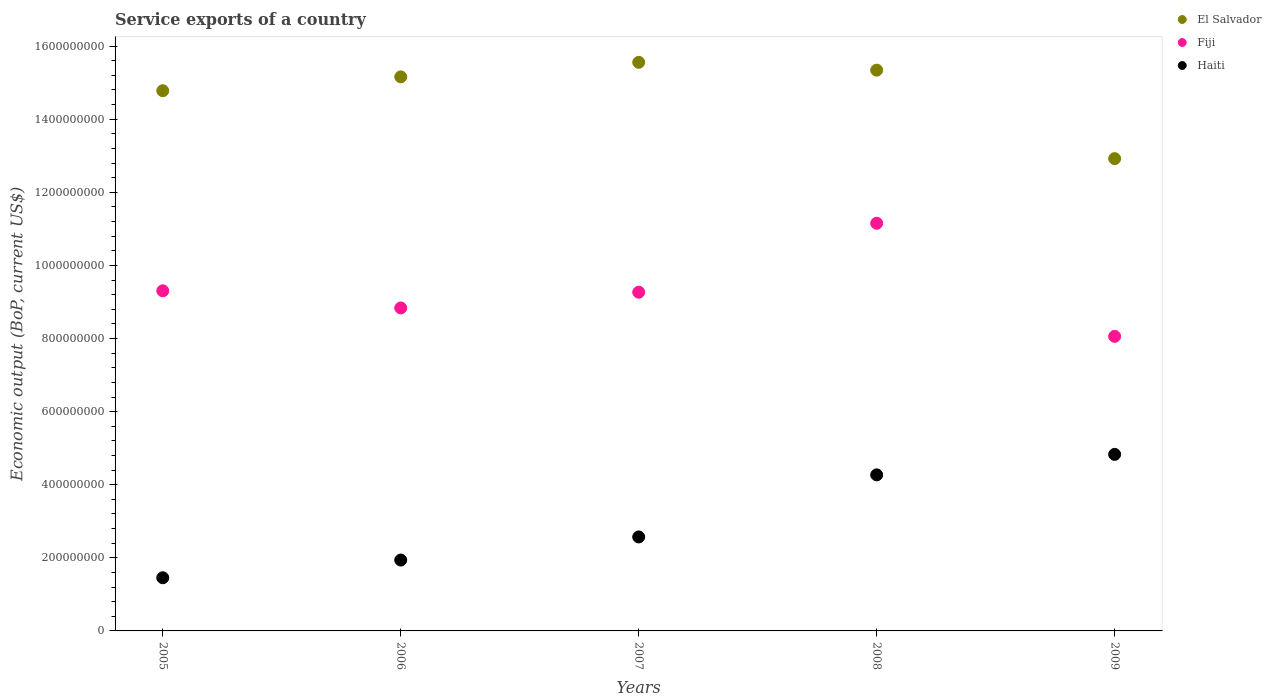What is the service exports in Haiti in 2009?
Make the answer very short. 4.83e+08. Across all years, what is the maximum service exports in Haiti?
Your answer should be compact. 4.83e+08. Across all years, what is the minimum service exports in El Salvador?
Your answer should be very brief. 1.29e+09. In which year was the service exports in El Salvador maximum?
Your answer should be compact. 2007. What is the total service exports in Haiti in the graph?
Keep it short and to the point. 1.51e+09. What is the difference between the service exports in Fiji in 2007 and that in 2008?
Provide a succinct answer. -1.89e+08. What is the difference between the service exports in Haiti in 2006 and the service exports in El Salvador in 2007?
Provide a succinct answer. -1.36e+09. What is the average service exports in Fiji per year?
Make the answer very short. 9.32e+08. In the year 2006, what is the difference between the service exports in Fiji and service exports in El Salvador?
Provide a short and direct response. -6.32e+08. In how many years, is the service exports in Fiji greater than 1040000000 US$?
Offer a very short reply. 1. What is the ratio of the service exports in El Salvador in 2005 to that in 2007?
Give a very brief answer. 0.95. What is the difference between the highest and the second highest service exports in El Salvador?
Make the answer very short. 2.14e+07. What is the difference between the highest and the lowest service exports in El Salvador?
Provide a succinct answer. 2.63e+08. Is it the case that in every year, the sum of the service exports in El Salvador and service exports in Haiti  is greater than the service exports in Fiji?
Offer a very short reply. Yes. Does the service exports in Haiti monotonically increase over the years?
Your response must be concise. Yes. Are the values on the major ticks of Y-axis written in scientific E-notation?
Make the answer very short. No. Does the graph contain grids?
Ensure brevity in your answer.  No. How are the legend labels stacked?
Offer a very short reply. Vertical. What is the title of the graph?
Keep it short and to the point. Service exports of a country. What is the label or title of the Y-axis?
Provide a short and direct response. Economic output (BoP, current US$). What is the Economic output (BoP, current US$) of El Salvador in 2005?
Offer a terse response. 1.48e+09. What is the Economic output (BoP, current US$) in Fiji in 2005?
Offer a very short reply. 9.31e+08. What is the Economic output (BoP, current US$) of Haiti in 2005?
Your response must be concise. 1.45e+08. What is the Economic output (BoP, current US$) of El Salvador in 2006?
Offer a terse response. 1.52e+09. What is the Economic output (BoP, current US$) in Fiji in 2006?
Your answer should be compact. 8.84e+08. What is the Economic output (BoP, current US$) of Haiti in 2006?
Your answer should be compact. 1.94e+08. What is the Economic output (BoP, current US$) of El Salvador in 2007?
Offer a terse response. 1.56e+09. What is the Economic output (BoP, current US$) of Fiji in 2007?
Offer a terse response. 9.27e+08. What is the Economic output (BoP, current US$) of Haiti in 2007?
Give a very brief answer. 2.57e+08. What is the Economic output (BoP, current US$) in El Salvador in 2008?
Ensure brevity in your answer.  1.53e+09. What is the Economic output (BoP, current US$) of Fiji in 2008?
Offer a very short reply. 1.12e+09. What is the Economic output (BoP, current US$) of Haiti in 2008?
Provide a succinct answer. 4.27e+08. What is the Economic output (BoP, current US$) of El Salvador in 2009?
Make the answer very short. 1.29e+09. What is the Economic output (BoP, current US$) in Fiji in 2009?
Your answer should be very brief. 8.06e+08. What is the Economic output (BoP, current US$) in Haiti in 2009?
Provide a succinct answer. 4.83e+08. Across all years, what is the maximum Economic output (BoP, current US$) in El Salvador?
Make the answer very short. 1.56e+09. Across all years, what is the maximum Economic output (BoP, current US$) in Fiji?
Make the answer very short. 1.12e+09. Across all years, what is the maximum Economic output (BoP, current US$) in Haiti?
Ensure brevity in your answer.  4.83e+08. Across all years, what is the minimum Economic output (BoP, current US$) of El Salvador?
Keep it short and to the point. 1.29e+09. Across all years, what is the minimum Economic output (BoP, current US$) in Fiji?
Offer a terse response. 8.06e+08. Across all years, what is the minimum Economic output (BoP, current US$) in Haiti?
Offer a very short reply. 1.45e+08. What is the total Economic output (BoP, current US$) in El Salvador in the graph?
Your answer should be compact. 7.38e+09. What is the total Economic output (BoP, current US$) of Fiji in the graph?
Your response must be concise. 4.66e+09. What is the total Economic output (BoP, current US$) in Haiti in the graph?
Your answer should be compact. 1.51e+09. What is the difference between the Economic output (BoP, current US$) of El Salvador in 2005 and that in 2006?
Keep it short and to the point. -3.79e+07. What is the difference between the Economic output (BoP, current US$) in Fiji in 2005 and that in 2006?
Ensure brevity in your answer.  4.68e+07. What is the difference between the Economic output (BoP, current US$) of Haiti in 2005 and that in 2006?
Offer a very short reply. -4.85e+07. What is the difference between the Economic output (BoP, current US$) of El Salvador in 2005 and that in 2007?
Offer a terse response. -7.76e+07. What is the difference between the Economic output (BoP, current US$) of Fiji in 2005 and that in 2007?
Your response must be concise. 3.80e+06. What is the difference between the Economic output (BoP, current US$) of Haiti in 2005 and that in 2007?
Offer a terse response. -1.12e+08. What is the difference between the Economic output (BoP, current US$) of El Salvador in 2005 and that in 2008?
Give a very brief answer. -5.62e+07. What is the difference between the Economic output (BoP, current US$) in Fiji in 2005 and that in 2008?
Give a very brief answer. -1.85e+08. What is the difference between the Economic output (BoP, current US$) in Haiti in 2005 and that in 2008?
Your answer should be compact. -2.82e+08. What is the difference between the Economic output (BoP, current US$) in El Salvador in 2005 and that in 2009?
Your answer should be compact. 1.86e+08. What is the difference between the Economic output (BoP, current US$) of Fiji in 2005 and that in 2009?
Your answer should be compact. 1.25e+08. What is the difference between the Economic output (BoP, current US$) in Haiti in 2005 and that in 2009?
Make the answer very short. -3.38e+08. What is the difference between the Economic output (BoP, current US$) in El Salvador in 2006 and that in 2007?
Offer a terse response. -3.97e+07. What is the difference between the Economic output (BoP, current US$) of Fiji in 2006 and that in 2007?
Offer a terse response. -4.30e+07. What is the difference between the Economic output (BoP, current US$) in Haiti in 2006 and that in 2007?
Offer a terse response. -6.32e+07. What is the difference between the Economic output (BoP, current US$) in El Salvador in 2006 and that in 2008?
Offer a very short reply. -1.83e+07. What is the difference between the Economic output (BoP, current US$) in Fiji in 2006 and that in 2008?
Make the answer very short. -2.32e+08. What is the difference between the Economic output (BoP, current US$) in Haiti in 2006 and that in 2008?
Ensure brevity in your answer.  -2.33e+08. What is the difference between the Economic output (BoP, current US$) in El Salvador in 2006 and that in 2009?
Keep it short and to the point. 2.24e+08. What is the difference between the Economic output (BoP, current US$) in Fiji in 2006 and that in 2009?
Provide a succinct answer. 7.78e+07. What is the difference between the Economic output (BoP, current US$) in Haiti in 2006 and that in 2009?
Ensure brevity in your answer.  -2.89e+08. What is the difference between the Economic output (BoP, current US$) in El Salvador in 2007 and that in 2008?
Offer a terse response. 2.14e+07. What is the difference between the Economic output (BoP, current US$) of Fiji in 2007 and that in 2008?
Your response must be concise. -1.89e+08. What is the difference between the Economic output (BoP, current US$) of Haiti in 2007 and that in 2008?
Your answer should be very brief. -1.70e+08. What is the difference between the Economic output (BoP, current US$) in El Salvador in 2007 and that in 2009?
Your answer should be very brief. 2.63e+08. What is the difference between the Economic output (BoP, current US$) in Fiji in 2007 and that in 2009?
Provide a short and direct response. 1.21e+08. What is the difference between the Economic output (BoP, current US$) of Haiti in 2007 and that in 2009?
Offer a terse response. -2.26e+08. What is the difference between the Economic output (BoP, current US$) of El Salvador in 2008 and that in 2009?
Give a very brief answer. 2.42e+08. What is the difference between the Economic output (BoP, current US$) in Fiji in 2008 and that in 2009?
Your answer should be compact. 3.09e+08. What is the difference between the Economic output (BoP, current US$) of Haiti in 2008 and that in 2009?
Your answer should be very brief. -5.60e+07. What is the difference between the Economic output (BoP, current US$) in El Salvador in 2005 and the Economic output (BoP, current US$) in Fiji in 2006?
Your answer should be very brief. 5.94e+08. What is the difference between the Economic output (BoP, current US$) in El Salvador in 2005 and the Economic output (BoP, current US$) in Haiti in 2006?
Offer a very short reply. 1.28e+09. What is the difference between the Economic output (BoP, current US$) of Fiji in 2005 and the Economic output (BoP, current US$) of Haiti in 2006?
Provide a succinct answer. 7.37e+08. What is the difference between the Economic output (BoP, current US$) in El Salvador in 2005 and the Economic output (BoP, current US$) in Fiji in 2007?
Ensure brevity in your answer.  5.51e+08. What is the difference between the Economic output (BoP, current US$) in El Salvador in 2005 and the Economic output (BoP, current US$) in Haiti in 2007?
Offer a very short reply. 1.22e+09. What is the difference between the Economic output (BoP, current US$) of Fiji in 2005 and the Economic output (BoP, current US$) of Haiti in 2007?
Provide a succinct answer. 6.73e+08. What is the difference between the Economic output (BoP, current US$) in El Salvador in 2005 and the Economic output (BoP, current US$) in Fiji in 2008?
Your answer should be very brief. 3.63e+08. What is the difference between the Economic output (BoP, current US$) in El Salvador in 2005 and the Economic output (BoP, current US$) in Haiti in 2008?
Provide a succinct answer. 1.05e+09. What is the difference between the Economic output (BoP, current US$) of Fiji in 2005 and the Economic output (BoP, current US$) of Haiti in 2008?
Provide a succinct answer. 5.04e+08. What is the difference between the Economic output (BoP, current US$) in El Salvador in 2005 and the Economic output (BoP, current US$) in Fiji in 2009?
Make the answer very short. 6.72e+08. What is the difference between the Economic output (BoP, current US$) of El Salvador in 2005 and the Economic output (BoP, current US$) of Haiti in 2009?
Make the answer very short. 9.95e+08. What is the difference between the Economic output (BoP, current US$) of Fiji in 2005 and the Economic output (BoP, current US$) of Haiti in 2009?
Offer a terse response. 4.48e+08. What is the difference between the Economic output (BoP, current US$) of El Salvador in 2006 and the Economic output (BoP, current US$) of Fiji in 2007?
Provide a succinct answer. 5.89e+08. What is the difference between the Economic output (BoP, current US$) in El Salvador in 2006 and the Economic output (BoP, current US$) in Haiti in 2007?
Your response must be concise. 1.26e+09. What is the difference between the Economic output (BoP, current US$) in Fiji in 2006 and the Economic output (BoP, current US$) in Haiti in 2007?
Your answer should be very brief. 6.27e+08. What is the difference between the Economic output (BoP, current US$) in El Salvador in 2006 and the Economic output (BoP, current US$) in Fiji in 2008?
Offer a terse response. 4.01e+08. What is the difference between the Economic output (BoP, current US$) in El Salvador in 2006 and the Economic output (BoP, current US$) in Haiti in 2008?
Your response must be concise. 1.09e+09. What is the difference between the Economic output (BoP, current US$) in Fiji in 2006 and the Economic output (BoP, current US$) in Haiti in 2008?
Offer a very short reply. 4.57e+08. What is the difference between the Economic output (BoP, current US$) of El Salvador in 2006 and the Economic output (BoP, current US$) of Fiji in 2009?
Make the answer very short. 7.10e+08. What is the difference between the Economic output (BoP, current US$) in El Salvador in 2006 and the Economic output (BoP, current US$) in Haiti in 2009?
Your answer should be compact. 1.03e+09. What is the difference between the Economic output (BoP, current US$) of Fiji in 2006 and the Economic output (BoP, current US$) of Haiti in 2009?
Provide a succinct answer. 4.01e+08. What is the difference between the Economic output (BoP, current US$) in El Salvador in 2007 and the Economic output (BoP, current US$) in Fiji in 2008?
Provide a short and direct response. 4.40e+08. What is the difference between the Economic output (BoP, current US$) in El Salvador in 2007 and the Economic output (BoP, current US$) in Haiti in 2008?
Offer a very short reply. 1.13e+09. What is the difference between the Economic output (BoP, current US$) of Fiji in 2007 and the Economic output (BoP, current US$) of Haiti in 2008?
Ensure brevity in your answer.  5.00e+08. What is the difference between the Economic output (BoP, current US$) of El Salvador in 2007 and the Economic output (BoP, current US$) of Fiji in 2009?
Provide a short and direct response. 7.50e+08. What is the difference between the Economic output (BoP, current US$) of El Salvador in 2007 and the Economic output (BoP, current US$) of Haiti in 2009?
Provide a short and direct response. 1.07e+09. What is the difference between the Economic output (BoP, current US$) of Fiji in 2007 and the Economic output (BoP, current US$) of Haiti in 2009?
Provide a succinct answer. 4.44e+08. What is the difference between the Economic output (BoP, current US$) in El Salvador in 2008 and the Economic output (BoP, current US$) in Fiji in 2009?
Provide a short and direct response. 7.28e+08. What is the difference between the Economic output (BoP, current US$) in El Salvador in 2008 and the Economic output (BoP, current US$) in Haiti in 2009?
Your answer should be very brief. 1.05e+09. What is the difference between the Economic output (BoP, current US$) of Fiji in 2008 and the Economic output (BoP, current US$) of Haiti in 2009?
Your answer should be very brief. 6.32e+08. What is the average Economic output (BoP, current US$) of El Salvador per year?
Your answer should be compact. 1.48e+09. What is the average Economic output (BoP, current US$) in Fiji per year?
Your response must be concise. 9.32e+08. What is the average Economic output (BoP, current US$) in Haiti per year?
Keep it short and to the point. 3.01e+08. In the year 2005, what is the difference between the Economic output (BoP, current US$) in El Salvador and Economic output (BoP, current US$) in Fiji?
Give a very brief answer. 5.47e+08. In the year 2005, what is the difference between the Economic output (BoP, current US$) of El Salvador and Economic output (BoP, current US$) of Haiti?
Make the answer very short. 1.33e+09. In the year 2005, what is the difference between the Economic output (BoP, current US$) of Fiji and Economic output (BoP, current US$) of Haiti?
Offer a very short reply. 7.85e+08. In the year 2006, what is the difference between the Economic output (BoP, current US$) in El Salvador and Economic output (BoP, current US$) in Fiji?
Offer a terse response. 6.32e+08. In the year 2006, what is the difference between the Economic output (BoP, current US$) of El Salvador and Economic output (BoP, current US$) of Haiti?
Make the answer very short. 1.32e+09. In the year 2006, what is the difference between the Economic output (BoP, current US$) in Fiji and Economic output (BoP, current US$) in Haiti?
Ensure brevity in your answer.  6.90e+08. In the year 2007, what is the difference between the Economic output (BoP, current US$) in El Salvador and Economic output (BoP, current US$) in Fiji?
Give a very brief answer. 6.29e+08. In the year 2007, what is the difference between the Economic output (BoP, current US$) of El Salvador and Economic output (BoP, current US$) of Haiti?
Provide a short and direct response. 1.30e+09. In the year 2007, what is the difference between the Economic output (BoP, current US$) in Fiji and Economic output (BoP, current US$) in Haiti?
Your answer should be very brief. 6.70e+08. In the year 2008, what is the difference between the Economic output (BoP, current US$) in El Salvador and Economic output (BoP, current US$) in Fiji?
Give a very brief answer. 4.19e+08. In the year 2008, what is the difference between the Economic output (BoP, current US$) of El Salvador and Economic output (BoP, current US$) of Haiti?
Give a very brief answer. 1.11e+09. In the year 2008, what is the difference between the Economic output (BoP, current US$) in Fiji and Economic output (BoP, current US$) in Haiti?
Your response must be concise. 6.88e+08. In the year 2009, what is the difference between the Economic output (BoP, current US$) of El Salvador and Economic output (BoP, current US$) of Fiji?
Provide a succinct answer. 4.86e+08. In the year 2009, what is the difference between the Economic output (BoP, current US$) in El Salvador and Economic output (BoP, current US$) in Haiti?
Give a very brief answer. 8.09e+08. In the year 2009, what is the difference between the Economic output (BoP, current US$) of Fiji and Economic output (BoP, current US$) of Haiti?
Offer a very short reply. 3.23e+08. What is the ratio of the Economic output (BoP, current US$) in El Salvador in 2005 to that in 2006?
Offer a terse response. 0.97. What is the ratio of the Economic output (BoP, current US$) in Fiji in 2005 to that in 2006?
Make the answer very short. 1.05. What is the ratio of the Economic output (BoP, current US$) in Haiti in 2005 to that in 2006?
Give a very brief answer. 0.75. What is the ratio of the Economic output (BoP, current US$) in El Salvador in 2005 to that in 2007?
Make the answer very short. 0.95. What is the ratio of the Economic output (BoP, current US$) in Haiti in 2005 to that in 2007?
Provide a succinct answer. 0.57. What is the ratio of the Economic output (BoP, current US$) in El Salvador in 2005 to that in 2008?
Offer a very short reply. 0.96. What is the ratio of the Economic output (BoP, current US$) of Fiji in 2005 to that in 2008?
Provide a short and direct response. 0.83. What is the ratio of the Economic output (BoP, current US$) in Haiti in 2005 to that in 2008?
Make the answer very short. 0.34. What is the ratio of the Economic output (BoP, current US$) of El Salvador in 2005 to that in 2009?
Your answer should be compact. 1.14. What is the ratio of the Economic output (BoP, current US$) of Fiji in 2005 to that in 2009?
Give a very brief answer. 1.15. What is the ratio of the Economic output (BoP, current US$) in Haiti in 2005 to that in 2009?
Provide a short and direct response. 0.3. What is the ratio of the Economic output (BoP, current US$) in El Salvador in 2006 to that in 2007?
Offer a very short reply. 0.97. What is the ratio of the Economic output (BoP, current US$) of Fiji in 2006 to that in 2007?
Provide a short and direct response. 0.95. What is the ratio of the Economic output (BoP, current US$) of Haiti in 2006 to that in 2007?
Your response must be concise. 0.75. What is the ratio of the Economic output (BoP, current US$) of Fiji in 2006 to that in 2008?
Provide a succinct answer. 0.79. What is the ratio of the Economic output (BoP, current US$) in Haiti in 2006 to that in 2008?
Your answer should be compact. 0.45. What is the ratio of the Economic output (BoP, current US$) in El Salvador in 2006 to that in 2009?
Offer a very short reply. 1.17. What is the ratio of the Economic output (BoP, current US$) of Fiji in 2006 to that in 2009?
Ensure brevity in your answer.  1.1. What is the ratio of the Economic output (BoP, current US$) of Haiti in 2006 to that in 2009?
Your answer should be compact. 0.4. What is the ratio of the Economic output (BoP, current US$) in Fiji in 2007 to that in 2008?
Give a very brief answer. 0.83. What is the ratio of the Economic output (BoP, current US$) in Haiti in 2007 to that in 2008?
Provide a short and direct response. 0.6. What is the ratio of the Economic output (BoP, current US$) in El Salvador in 2007 to that in 2009?
Provide a succinct answer. 1.2. What is the ratio of the Economic output (BoP, current US$) in Fiji in 2007 to that in 2009?
Offer a terse response. 1.15. What is the ratio of the Economic output (BoP, current US$) in Haiti in 2007 to that in 2009?
Your answer should be compact. 0.53. What is the ratio of the Economic output (BoP, current US$) in El Salvador in 2008 to that in 2009?
Ensure brevity in your answer.  1.19. What is the ratio of the Economic output (BoP, current US$) in Fiji in 2008 to that in 2009?
Ensure brevity in your answer.  1.38. What is the ratio of the Economic output (BoP, current US$) in Haiti in 2008 to that in 2009?
Provide a succinct answer. 0.88. What is the difference between the highest and the second highest Economic output (BoP, current US$) in El Salvador?
Give a very brief answer. 2.14e+07. What is the difference between the highest and the second highest Economic output (BoP, current US$) in Fiji?
Provide a succinct answer. 1.85e+08. What is the difference between the highest and the second highest Economic output (BoP, current US$) in Haiti?
Your response must be concise. 5.60e+07. What is the difference between the highest and the lowest Economic output (BoP, current US$) in El Salvador?
Your response must be concise. 2.63e+08. What is the difference between the highest and the lowest Economic output (BoP, current US$) in Fiji?
Offer a very short reply. 3.09e+08. What is the difference between the highest and the lowest Economic output (BoP, current US$) in Haiti?
Your response must be concise. 3.38e+08. 